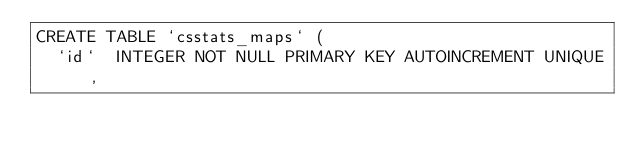Convert code to text. <code><loc_0><loc_0><loc_500><loc_500><_SQL_>CREATE TABLE `csstats_maps` (
	`id`	INTEGER NOT NULL PRIMARY KEY AUTOINCREMENT UNIQUE,</code> 